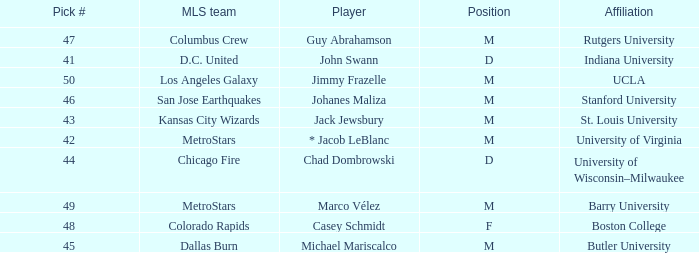What position has UCLA pick that is larger than #47? M. 